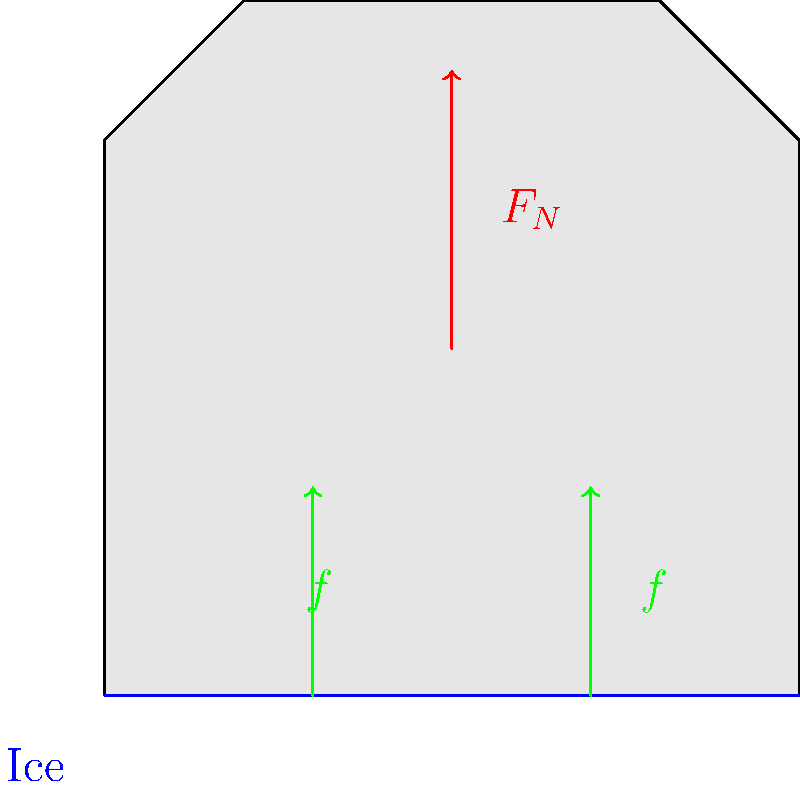In the context of attracting businesses to Anchorage, consider the importance of safe footwear for workers in icy conditions. The diagram shows a boot on an icy surface with normal force $F_N$ and friction forces $f$. If the coefficient of static friction is $\mu_s = 0.3$ and the weight of the person is $800 \text{ N}$, what is the maximum horizontal force the person can apply before slipping? To solve this problem, we'll follow these steps:

1. Identify the relevant forces:
   - Normal force ($F_N$) acting upwards
   - Friction forces ($f$) acting horizontally
   - Weight of the person ($W = 800 \text{ N}$) acting downwards

2. Recall the relationship between normal force and weight:
   $F_N = W = 800 \text{ N}$

3. Use the formula for maximum static friction:
   $f_{max} = \mu_s \cdot F_N$

4. Calculate the maximum friction force:
   $f_{max} = 0.3 \cdot 800 \text{ N} = 240 \text{ N}$

5. The maximum horizontal force the person can apply before slipping is equal to the maximum friction force, which is 240 N.

This analysis is crucial for understanding the safety requirements of workers in Anchorage's icy conditions, which can influence business decisions and policy-making related to workplace safety and infrastructure development.
Answer: 240 N 